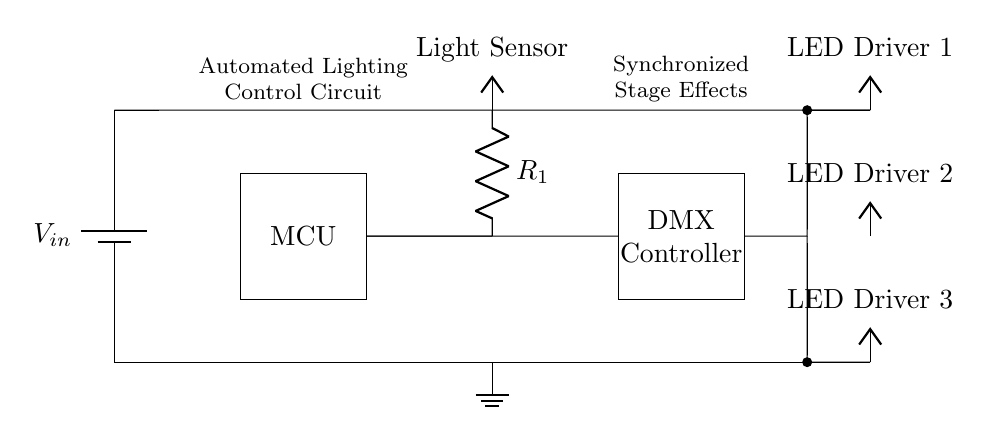What is the main component of this circuit? The main component in this circuit is the microcontroller, which is represented by the rectangle labeled "MCU". This component is essential for processing inputs and controlling outputs within the automated lighting control system.
Answer: microcontroller How many LED drivers are present in this circuit? There are three LED drivers in the circuit, as indicated by the three separate sections labeled "LED Driver 1," "LED Driver 2," and "LED Driver 3" respectively at the right side of the diagram.
Answer: three What is the function of the light sensor in this circuit? The light sensor detects ambient light levels and sends this information to the microcontroller, which uses it to adjust the illumination of the stage lighting accordingly. This interaction is essential for achieving synchronized stage effects.
Answer: detects light Which component is responsible for DMX control? The DMX controller is responsible for managing the digital multiplexing protocol used in stage lighting control systems, represented by the rectangle labeled "DMX Controller". It receives signals from the microcontroller and communicates with the LED drivers.
Answer: DMX Controller What is the voltage supplied by the battery in this circuit? The voltage is represented as "V_in" at the top of the circuit, indicating the input voltage supplied by the battery. The exact value of V_in is not specified in the diagram but is critical for operating the entire circuit.
Answer: V_in Which two components are connected directly to the microcontroller? The light sensor and the DMX controller are connected to the microcontroller; the light sensor is connected through a resistor, while the DMX controller has a direct connection. This shows the flow of information from the sensor to the controller for processing.
Answer: light sensor, DMX controller What is the purpose of the ground in the circuit? The ground serves as a common return path for electric current and as a reference point for voltage measurements within the circuit. In this diagram, it is indicated at the bottom and is connected to all LED drivers and the microcontroller.
Answer: common return path 